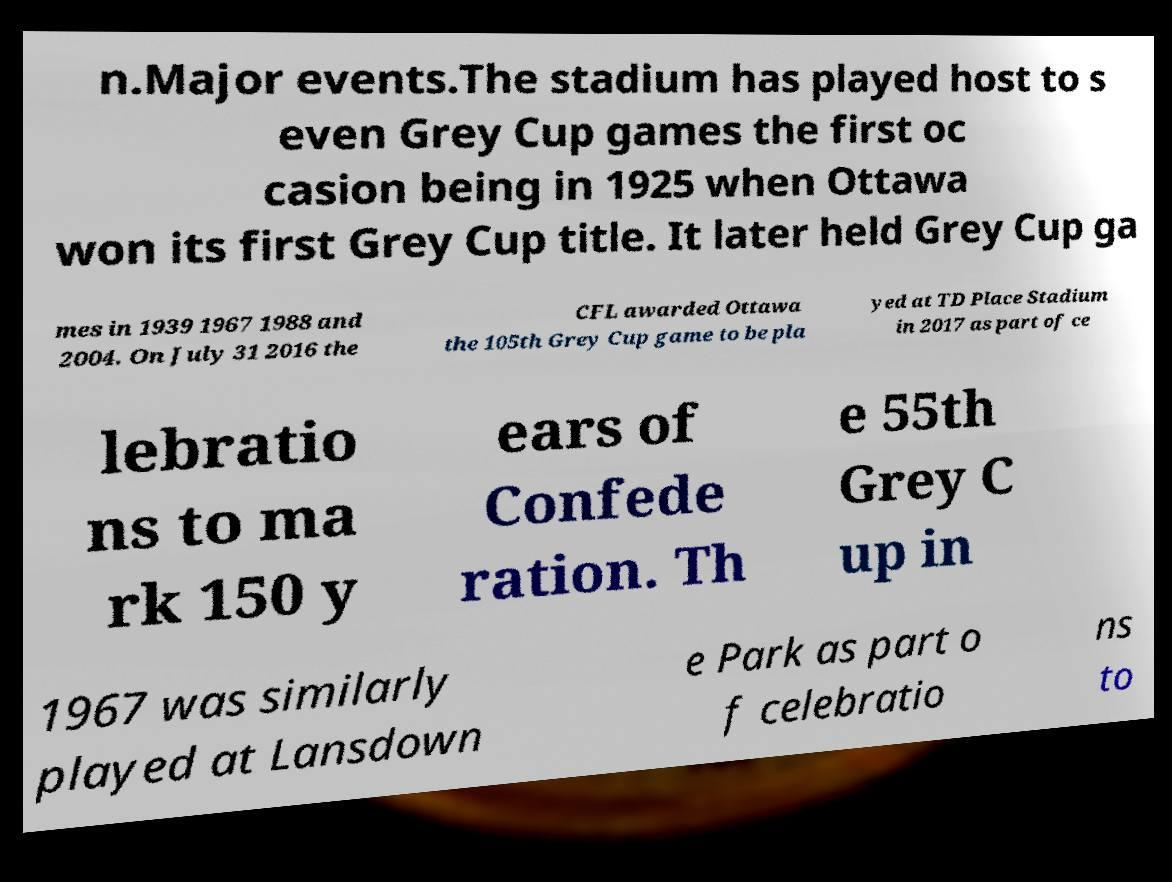Could you assist in decoding the text presented in this image and type it out clearly? n.Major events.The stadium has played host to s even Grey Cup games the first oc casion being in 1925 when Ottawa won its first Grey Cup title. It later held Grey Cup ga mes in 1939 1967 1988 and 2004. On July 31 2016 the CFL awarded Ottawa the 105th Grey Cup game to be pla yed at TD Place Stadium in 2017 as part of ce lebratio ns to ma rk 150 y ears of Confede ration. Th e 55th Grey C up in 1967 was similarly played at Lansdown e Park as part o f celebratio ns to 